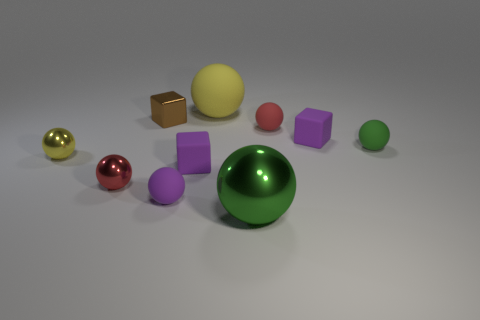How many blocks are the same size as the red rubber object?
Offer a very short reply. 3. How many small red things are there?
Your answer should be compact. 2. Do the large yellow sphere and the purple cube on the right side of the big green metallic object have the same material?
Your response must be concise. Yes. How many red things are tiny spheres or balls?
Ensure brevity in your answer.  2. There is a green object that is made of the same material as the big yellow ball; what is its size?
Your answer should be very brief. Small. How many small cyan rubber objects are the same shape as the large matte object?
Ensure brevity in your answer.  0. Are there more small purple balls that are right of the green matte object than big yellow things left of the big yellow sphere?
Offer a terse response. No. Do the large metal object and the small sphere on the right side of the red rubber ball have the same color?
Provide a short and direct response. Yes. There is a thing that is the same size as the yellow rubber ball; what is its material?
Your answer should be very brief. Metal. What number of objects are either brown metallic objects or tiny matte objects that are on the left side of the big rubber thing?
Keep it short and to the point. 3. 